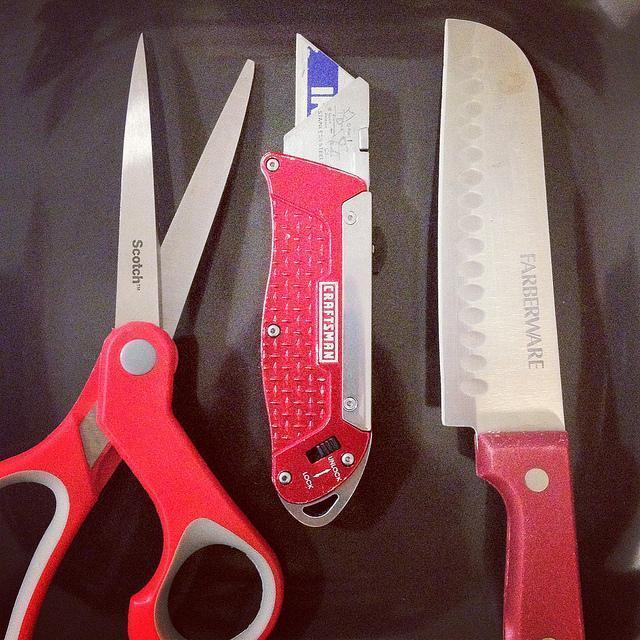How many knives can be seen?
Give a very brief answer. 2. 